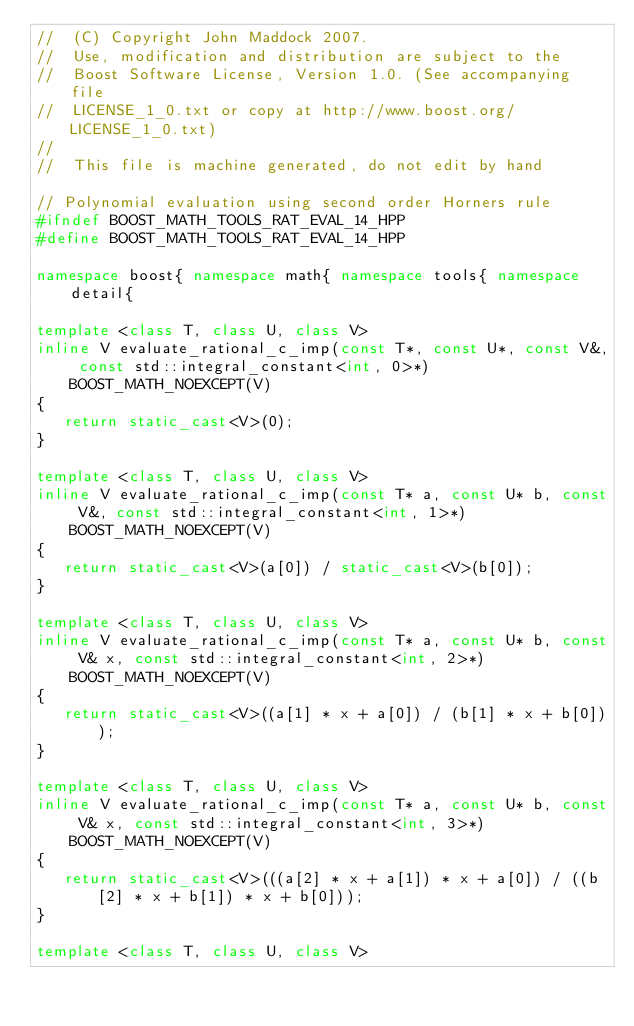Convert code to text. <code><loc_0><loc_0><loc_500><loc_500><_C++_>//  (C) Copyright John Maddock 2007.
//  Use, modification and distribution are subject to the
//  Boost Software License, Version 1.0. (See accompanying file
//  LICENSE_1_0.txt or copy at http://www.boost.org/LICENSE_1_0.txt)
//
//  This file is machine generated, do not edit by hand

// Polynomial evaluation using second order Horners rule
#ifndef BOOST_MATH_TOOLS_RAT_EVAL_14_HPP
#define BOOST_MATH_TOOLS_RAT_EVAL_14_HPP

namespace boost{ namespace math{ namespace tools{ namespace detail{

template <class T, class U, class V>
inline V evaluate_rational_c_imp(const T*, const U*, const V&, const std::integral_constant<int, 0>*) BOOST_MATH_NOEXCEPT(V)
{
   return static_cast<V>(0);
}

template <class T, class U, class V>
inline V evaluate_rational_c_imp(const T* a, const U* b, const V&, const std::integral_constant<int, 1>*) BOOST_MATH_NOEXCEPT(V)
{
   return static_cast<V>(a[0]) / static_cast<V>(b[0]);
}

template <class T, class U, class V>
inline V evaluate_rational_c_imp(const T* a, const U* b, const V& x, const std::integral_constant<int, 2>*) BOOST_MATH_NOEXCEPT(V)
{
   return static_cast<V>((a[1] * x + a[0]) / (b[1] * x + b[0]));
}

template <class T, class U, class V>
inline V evaluate_rational_c_imp(const T* a, const U* b, const V& x, const std::integral_constant<int, 3>*) BOOST_MATH_NOEXCEPT(V)
{
   return static_cast<V>(((a[2] * x + a[1]) * x + a[0]) / ((b[2] * x + b[1]) * x + b[0]));
}

template <class T, class U, class V></code> 